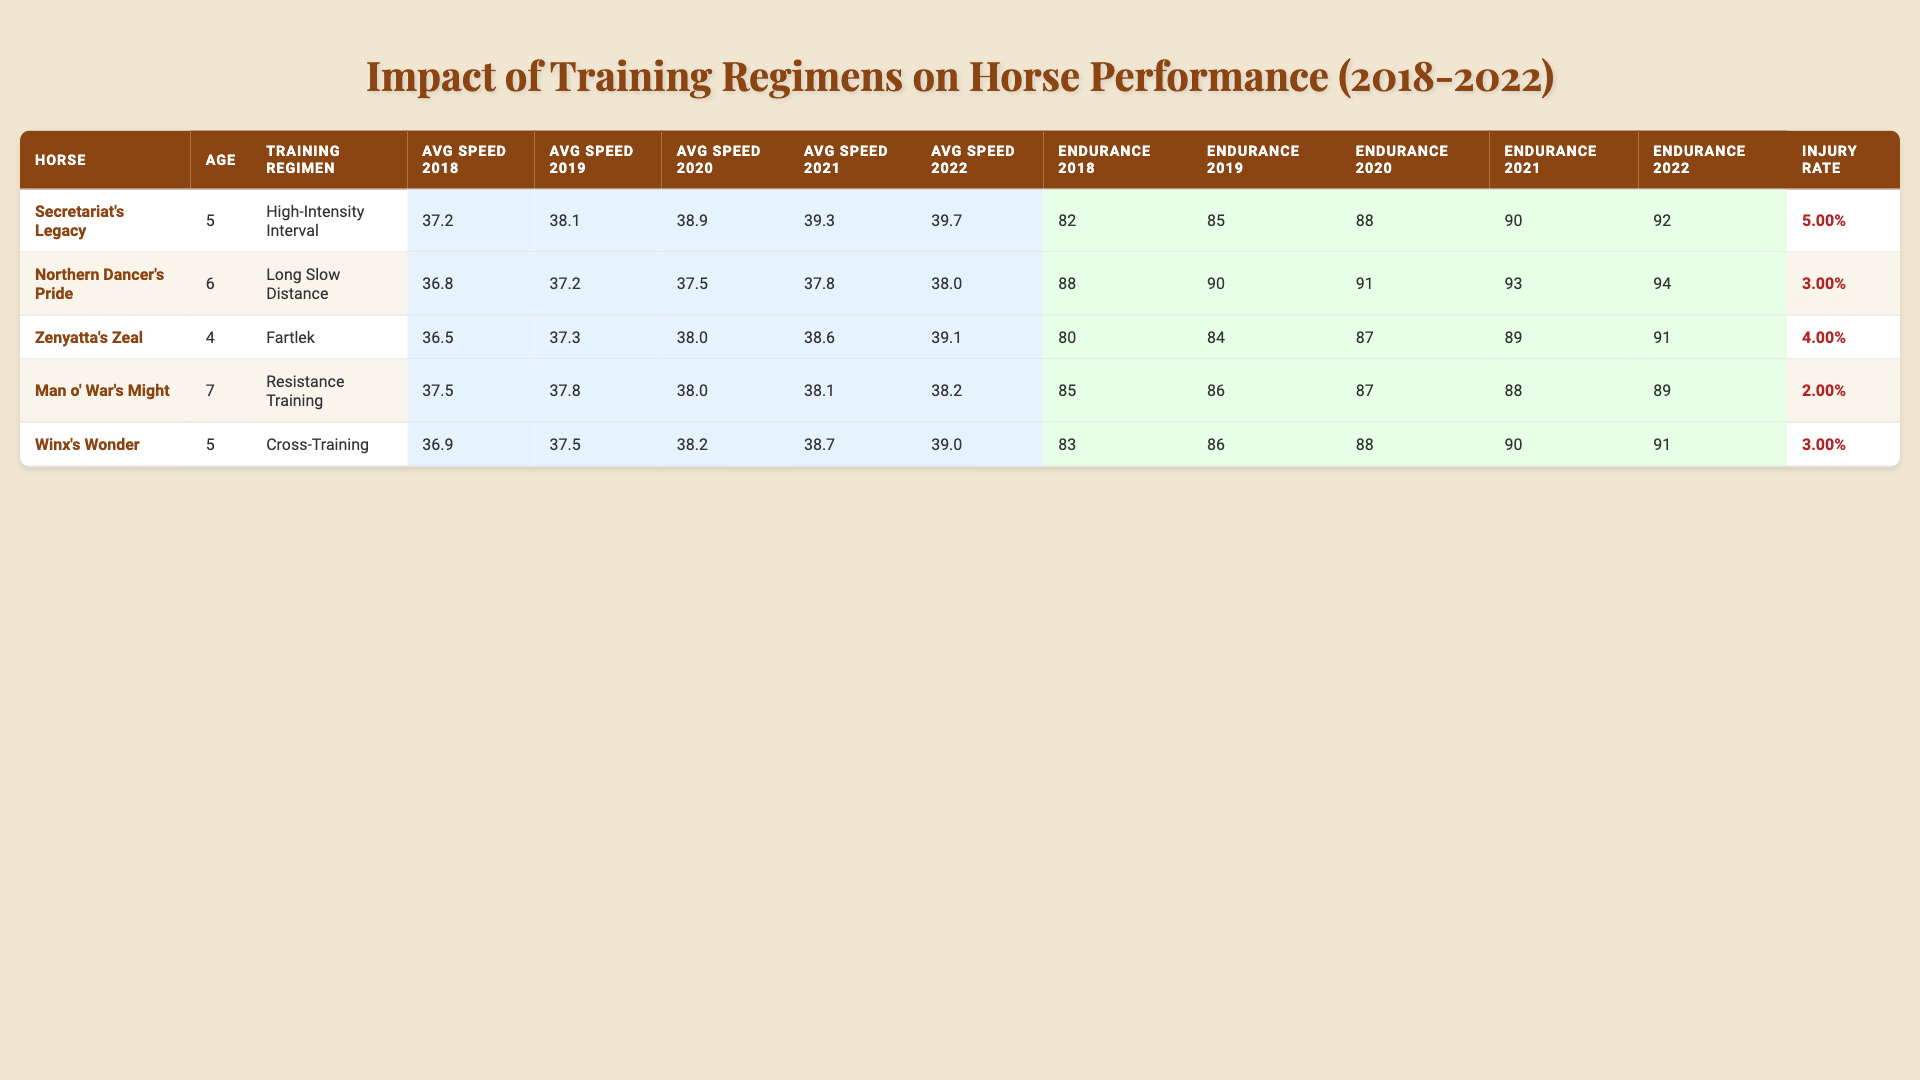What was the average speed of Secretariat's Legacy in 2021? The average speed of Secretariat's Legacy in 2021 is presented in the table under the column for Avg Speed 2021. The value is 39.3.
Answer: 39.3 Which horse had the highest endurance score in 2022? By examining the endurance scores for each horse in 2022, we find that "Northern Dancer's Pride" has the highest endurance score of 94.
Answer: Northern Dancer's Pride What is the injury rate of Man o' War's Might? The injury rate for Man o' War's Might is specified in the last column of the table. It is 0.02, which translates to 2%.
Answer: 0.02 What is the average speed of Zenyatta's Zeal over the five years? To find the average speed over the five years, we add the avg speeds from 2018 to 2022: 36.5 + 37.3 + 38.0 + 38.6 + 39.1 = 189.5. Next, divide by 5 to get the average: 189.5 / 5 = 37.9.
Answer: 37.9 Which training regimen corresponds to the horse with the lowest injury rate? The horse with the lowest injury rate is Man o' War's Might with an injury rate of 0.02 (2%). This horse follows the "Resistance Training" regimen.
Answer: Resistance Training Did any horse have a decrease in its average speed from 2020 to 2021? By analyzing the average speeds from 2020 and 2021 for each horse, we see that no horse shows a decrease; all have either increased or remained stable.
Answer: No What is the difference in endurance score for Winx's Wonder from 2018 to 2022? The endurance score for Winx's Wonder in 2018 is 83, and in 2022 it is 91. The difference can be calculated as 91 - 83 = 8.
Answer: 8 Which horse showed the biggest increase in average speed from 2018 to 2022? To find this, we calculate the increase in average speed for each horse from 2018 to 2022. Secretariat's Legacy improved from 37.2 to 39.7, which is an increase of 2.5. Other horses’ increases were smaller, confirming Secretariat's Legacy had the largest increase.
Answer: Secretariat's Legacy What is the trend in the average speed of Northern Dancer's Pride over the five years? By looking at the average speeds from 2018 to 2022, Northern Dancer's Pride started at 36.8 and increased to 38.0 by 2022, indicating an upward trend over the years.
Answer: Upward trend Has Zenyatta's Zeal consistently improved its endurance score each year? The endurance scores for Zenyatta's Zeal show an increase every year: 80, 84, 87, 89, and 91 from 2018 to 2022, confirming consistent improvement.
Answer: Yes 